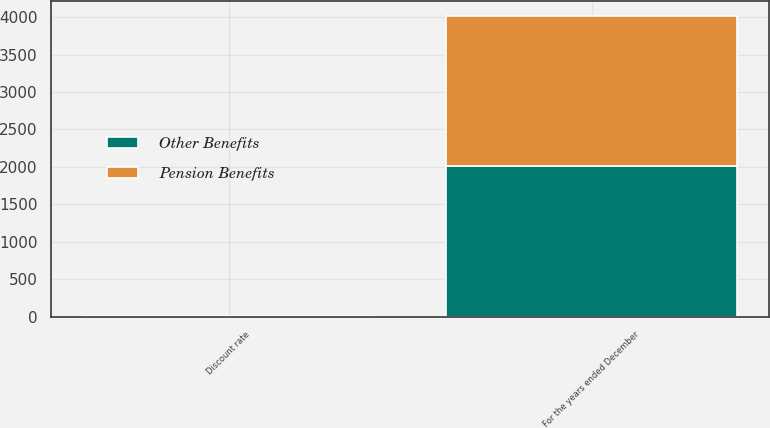<chart> <loc_0><loc_0><loc_500><loc_500><stacked_bar_chart><ecel><fcel>For the years ended December<fcel>Discount rate<nl><fcel>Other Benefits<fcel>2010<fcel>5.7<nl><fcel>Pension Benefits<fcel>2010<fcel>5.7<nl></chart> 